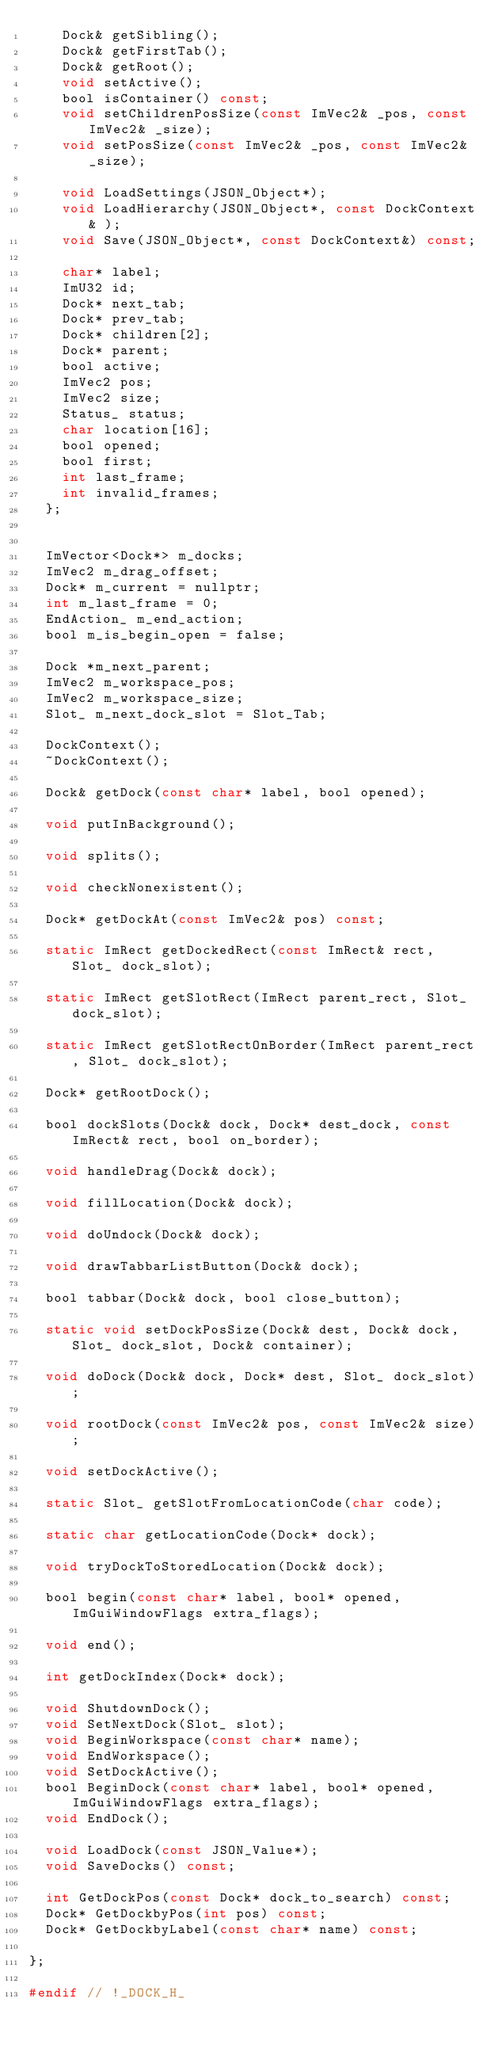<code> <loc_0><loc_0><loc_500><loc_500><_C_>		Dock& getSibling();
		Dock& getFirstTab();
		Dock& getRoot();
		void setActive();
		bool isContainer() const;
		void setChildrenPosSize(const ImVec2& _pos, const ImVec2& _size);
		void setPosSize(const ImVec2& _pos, const ImVec2& _size);

		void LoadSettings(JSON_Object*);
		void LoadHierarchy(JSON_Object*, const DockContext& );
		void Save(JSON_Object*, const DockContext&) const;

		char* label;
		ImU32 id;
		Dock* next_tab;
		Dock* prev_tab;
		Dock* children[2];
		Dock* parent;
		bool active;
		ImVec2 pos;
		ImVec2 size;
		Status_ status;
		char location[16];
		bool opened;
		bool first;
		int last_frame;
		int invalid_frames;
	};


	ImVector<Dock*> m_docks;
	ImVec2 m_drag_offset;
	Dock* m_current = nullptr;
	int m_last_frame = 0;
	EndAction_ m_end_action;
	bool m_is_begin_open = false;

	Dock *m_next_parent;
	ImVec2 m_workspace_pos;
	ImVec2 m_workspace_size;
	Slot_ m_next_dock_slot = Slot_Tab;

	DockContext();
	~DockContext();

	Dock& getDock(const char* label, bool opened);

	void putInBackground();

	void splits();

	void checkNonexistent();

	Dock* getDockAt(const ImVec2& pos) const;

	static ImRect getDockedRect(const ImRect& rect, Slot_ dock_slot);

	static ImRect getSlotRect(ImRect parent_rect, Slot_ dock_slot);

	static ImRect getSlotRectOnBorder(ImRect parent_rect, Slot_ dock_slot);

	Dock* getRootDock();

	bool dockSlots(Dock& dock, Dock* dest_dock, const ImRect& rect, bool on_border);

	void handleDrag(Dock& dock);

	void fillLocation(Dock& dock);

	void doUndock(Dock& dock);

	void drawTabbarListButton(Dock& dock);

	bool tabbar(Dock& dock, bool close_button);

	static void setDockPosSize(Dock& dest, Dock& dock, Slot_ dock_slot, Dock& container);

	void doDock(Dock& dock, Dock* dest, Slot_ dock_slot);

	void rootDock(const ImVec2& pos, const ImVec2& size);

	void setDockActive();

	static Slot_ getSlotFromLocationCode(char code);

	static char getLocationCode(Dock* dock);

	void tryDockToStoredLocation(Dock& dock);

	bool begin(const char* label, bool* opened, ImGuiWindowFlags extra_flags);

	void end();

	int getDockIndex(Dock* dock);

	void ShutdownDock();
	void SetNextDock(Slot_ slot);
	void BeginWorkspace(const char* name);
	void EndWorkspace();
	void SetDockActive();
	bool BeginDock(const char* label, bool* opened, ImGuiWindowFlags extra_flags);
	void EndDock();

	void LoadDock(const JSON_Value*);
	void SaveDocks() const;

	int GetDockPos(const Dock* dock_to_search) const;
	Dock* GetDockbyPos(int pos) const;
	Dock* GetDockbyLabel(const char* name) const;

};

#endif // !_DOCK_H_
</code> 